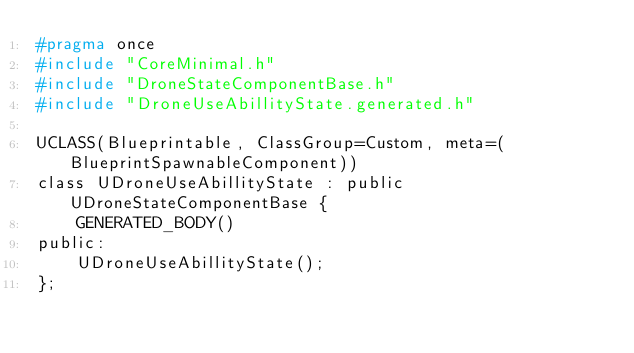<code> <loc_0><loc_0><loc_500><loc_500><_C_>#pragma once
#include "CoreMinimal.h"
#include "DroneStateComponentBase.h"
#include "DroneUseAbillityState.generated.h"

UCLASS(Blueprintable, ClassGroup=Custom, meta=(BlueprintSpawnableComponent))
class UDroneUseAbillityState : public UDroneStateComponentBase {
    GENERATED_BODY()
public:
    UDroneUseAbillityState();
};

</code> 